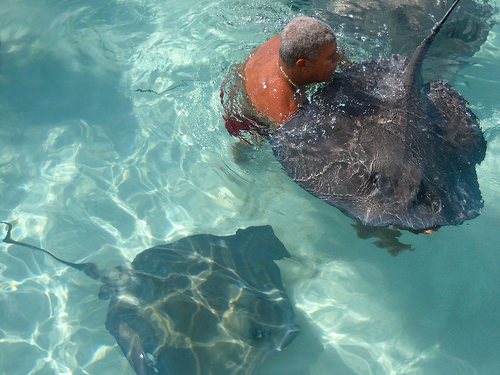<image>
Is there a swimmer above the sting ray? No. The swimmer is not positioned above the sting ray. The vertical arrangement shows a different relationship. 